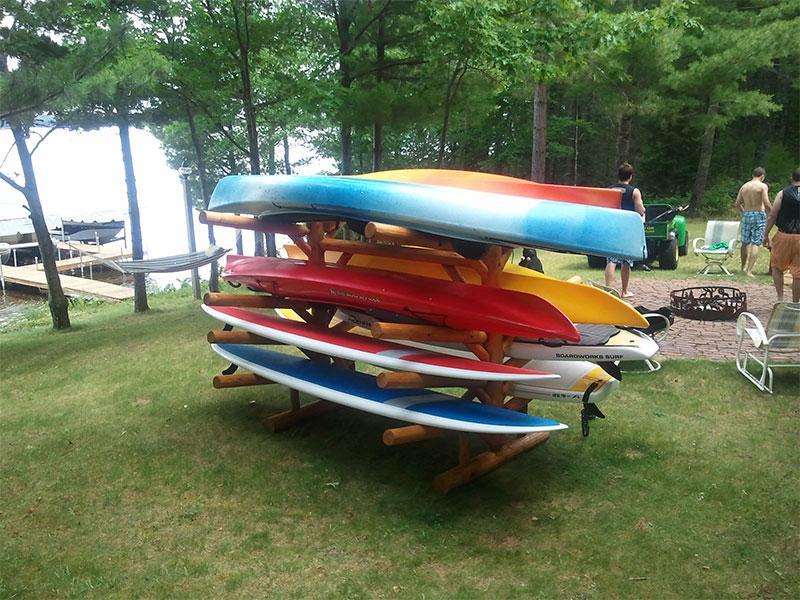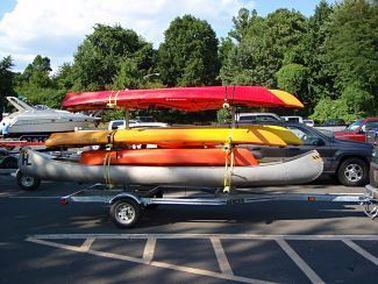The first image is the image on the left, the second image is the image on the right. Examine the images to the left and right. Is the description "Multiple boats are attached to the top of no less than one car" accurate? Answer yes or no. No. The first image is the image on the left, the second image is the image on the right. Examine the images to the left and right. Is the description "At least one image shows a dark red SUV with multiple canoes on top." accurate? Answer yes or no. No. 